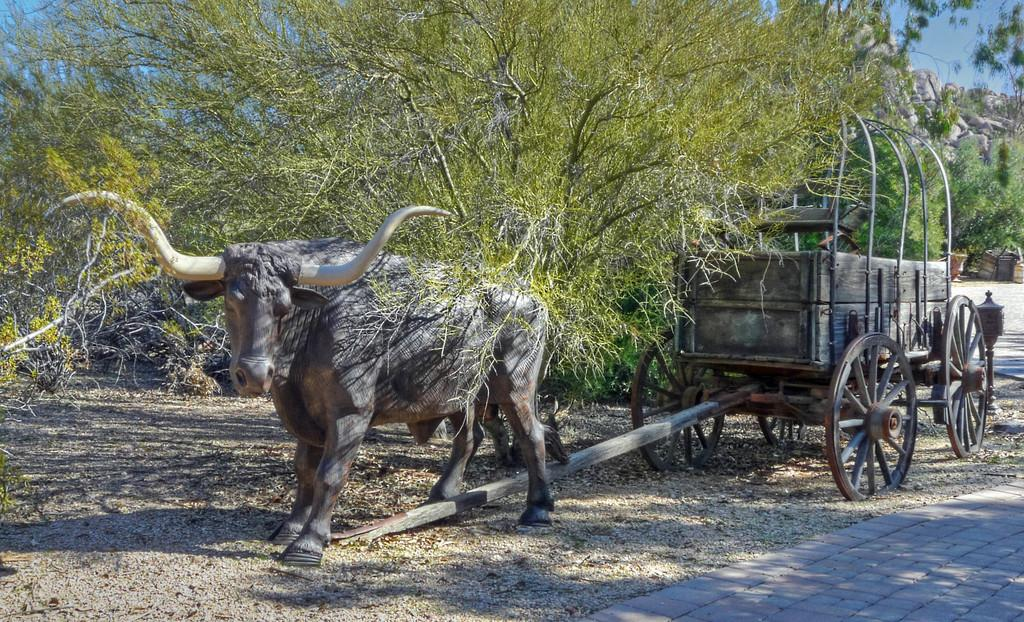What is the main subject of the image? There is a sculpture of a buffalo cart in the image. What can be seen in the background of the image? Trees and rocks are visible in the image. Can you hear the alarm going off in the image? There is no alarm present in the image, so it cannot be heard. 